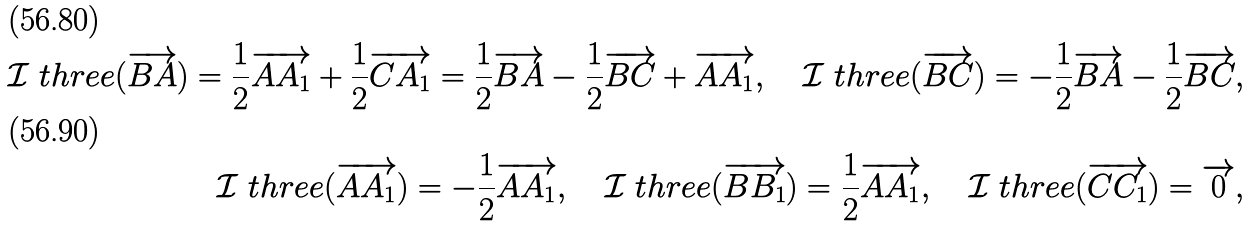<formula> <loc_0><loc_0><loc_500><loc_500>\mathcal { I } _ { \ } t h r e e ( \overrightarrow { B A } ) = \frac { 1 } { 2 } \overrightarrow { A A _ { 1 } } + \frac { 1 } { 2 } \overrightarrow { C A _ { 1 } } = \frac { 1 } { 2 } \overrightarrow { B A } - \frac { 1 } { 2 } \overrightarrow { B C } + \overrightarrow { A A _ { 1 } } , \quad \mathcal { I } _ { \ } t h r e e ( \overrightarrow { B C } ) = - \frac { 1 } { 2 } \overrightarrow { B A } - \frac { 1 } { 2 } \overrightarrow { B C } , \\ \mathcal { I } _ { \ } t h r e e ( \overrightarrow { A A _ { 1 } } ) = - \frac { 1 } { 2 } \overrightarrow { A A _ { 1 } } , \quad \mathcal { I } _ { \ } t h r e e ( \overrightarrow { B B _ { 1 } } ) = \frac { 1 } { 2 } \overrightarrow { A A _ { 1 } } , \quad \mathcal { I } _ { \ } t h r e e ( \overrightarrow { C C _ { 1 } } ) = \overrightarrow { 0 } ,</formula> 